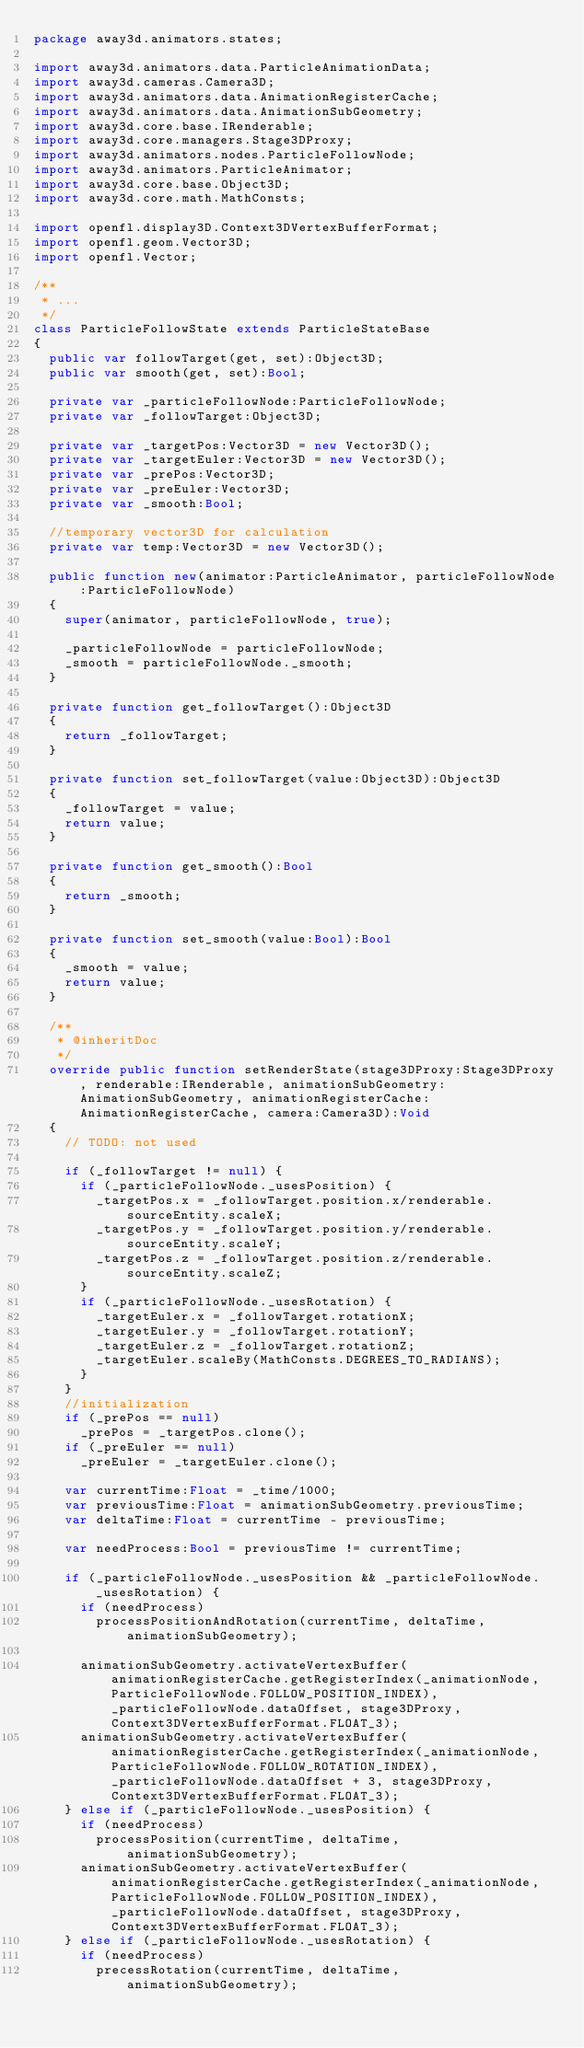<code> <loc_0><loc_0><loc_500><loc_500><_Haxe_>package away3d.animators.states;

import away3d.animators.data.ParticleAnimationData;
import away3d.cameras.Camera3D;
import away3d.animators.data.AnimationRegisterCache;
import away3d.animators.data.AnimationSubGeometry;
import away3d.core.base.IRenderable;
import away3d.core.managers.Stage3DProxy;
import away3d.animators.nodes.ParticleFollowNode;
import away3d.animators.ParticleAnimator;
import away3d.core.base.Object3D;
import away3d.core.math.MathConsts;

import openfl.display3D.Context3DVertexBufferFormat;
import openfl.geom.Vector3D;
import openfl.Vector;

/**
 * ...
 */
class ParticleFollowState extends ParticleStateBase
{
	public var followTarget(get, set):Object3D;
	public var smooth(get, set):Bool;
	
	private var _particleFollowNode:ParticleFollowNode;
	private var _followTarget:Object3D;
	
	private var _targetPos:Vector3D = new Vector3D();
	private var _targetEuler:Vector3D = new Vector3D();
	private var _prePos:Vector3D;
	private var _preEuler:Vector3D;
	private var _smooth:Bool;
	
	//temporary vector3D for calculation
	private var temp:Vector3D = new Vector3D();
	
	public function new(animator:ParticleAnimator, particleFollowNode:ParticleFollowNode)
	{
		super(animator, particleFollowNode, true);
		
		_particleFollowNode = particleFollowNode;
		_smooth = particleFollowNode._smooth;
	}
	
	private function get_followTarget():Object3D
	{
		return _followTarget;
	}
	
	private function set_followTarget(value:Object3D):Object3D
	{
		_followTarget = value;
		return value;
	}
	
	private function get_smooth():Bool
	{
		return _smooth;
	}
	
	private function set_smooth(value:Bool):Bool
	{
		_smooth = value;
		return value;
	}
	
	/**
	 * @inheritDoc
	 */
	override public function setRenderState(stage3DProxy:Stage3DProxy, renderable:IRenderable, animationSubGeometry:AnimationSubGeometry, animationRegisterCache:AnimationRegisterCache, camera:Camera3D):Void
	{
		// TODO: not used
		
		if (_followTarget != null) {
			if (_particleFollowNode._usesPosition) {
				_targetPos.x = _followTarget.position.x/renderable.sourceEntity.scaleX;
				_targetPos.y = _followTarget.position.y/renderable.sourceEntity.scaleY;
				_targetPos.z = _followTarget.position.z/renderable.sourceEntity.scaleZ;
			}
			if (_particleFollowNode._usesRotation) {
				_targetEuler.x = _followTarget.rotationX;
				_targetEuler.y = _followTarget.rotationY;
				_targetEuler.z = _followTarget.rotationZ;
				_targetEuler.scaleBy(MathConsts.DEGREES_TO_RADIANS);
			}
		}
		//initialization
		if (_prePos == null)
			_prePos = _targetPos.clone();
		if (_preEuler == null)
			_preEuler = _targetEuler.clone();
		
		var currentTime:Float = _time/1000;
		var previousTime:Float = animationSubGeometry.previousTime;
		var deltaTime:Float = currentTime - previousTime;
		
		var needProcess:Bool = previousTime != currentTime;
		
		if (_particleFollowNode._usesPosition && _particleFollowNode._usesRotation) {
			if (needProcess)
				processPositionAndRotation(currentTime, deltaTime, animationSubGeometry);
			
			animationSubGeometry.activateVertexBuffer(animationRegisterCache.getRegisterIndex(_animationNode, ParticleFollowNode.FOLLOW_POSITION_INDEX), _particleFollowNode.dataOffset, stage3DProxy, Context3DVertexBufferFormat.FLOAT_3);
			animationSubGeometry.activateVertexBuffer(animationRegisterCache.getRegisterIndex(_animationNode, ParticleFollowNode.FOLLOW_ROTATION_INDEX), _particleFollowNode.dataOffset + 3, stage3DProxy, Context3DVertexBufferFormat.FLOAT_3);
		} else if (_particleFollowNode._usesPosition) {
			if (needProcess)
				processPosition(currentTime, deltaTime, animationSubGeometry);
			animationSubGeometry.activateVertexBuffer(animationRegisterCache.getRegisterIndex(_animationNode, ParticleFollowNode.FOLLOW_POSITION_INDEX), _particleFollowNode.dataOffset, stage3DProxy, Context3DVertexBufferFormat.FLOAT_3);
		} else if (_particleFollowNode._usesRotation) {
			if (needProcess)
				precessRotation(currentTime, deltaTime, animationSubGeometry);</code> 